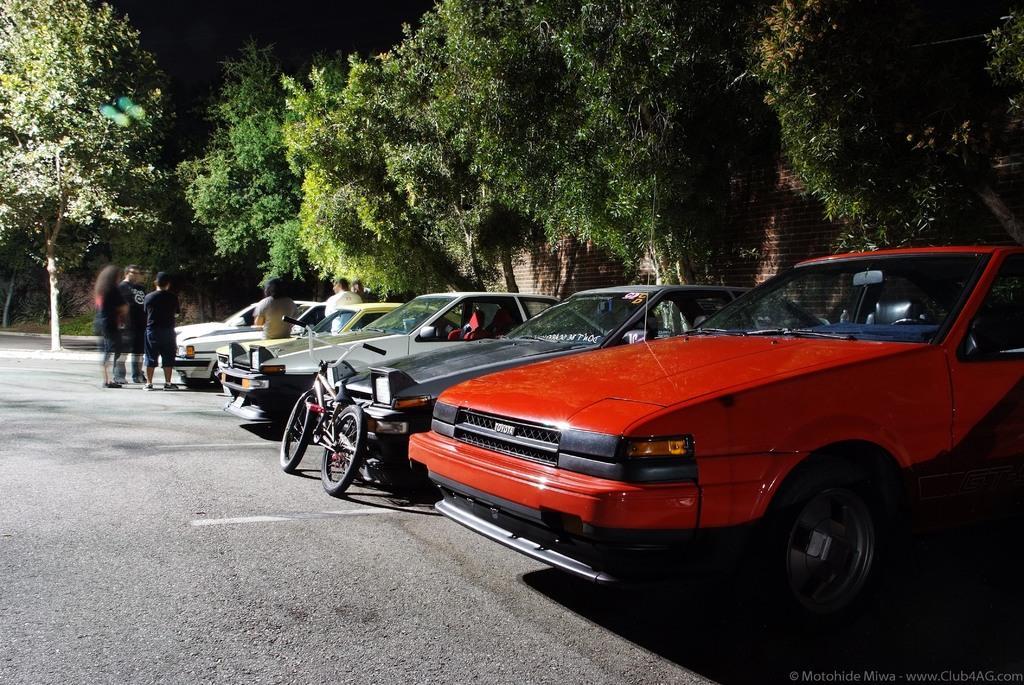In one or two sentences, can you explain what this image depicts? In this image I can see cars, a bicycle and people are standing on the road. I can see also trees and a brick wall. 